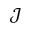<formula> <loc_0><loc_0><loc_500><loc_500>\mathcal { J }</formula> 